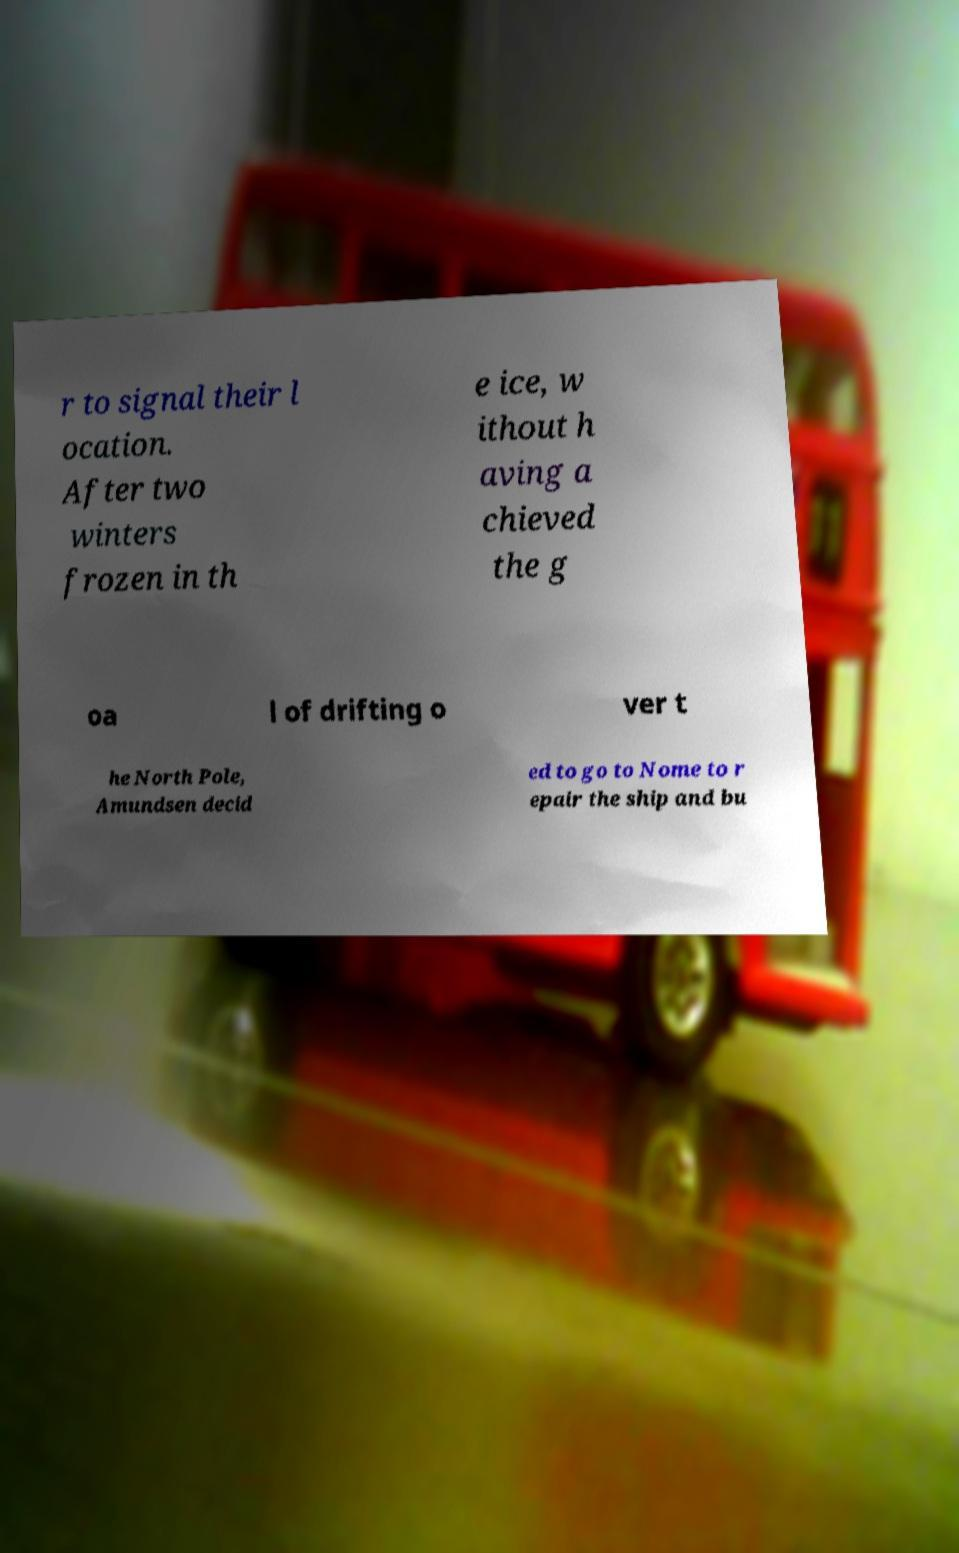Can you accurately transcribe the text from the provided image for me? r to signal their l ocation. After two winters frozen in th e ice, w ithout h aving a chieved the g oa l of drifting o ver t he North Pole, Amundsen decid ed to go to Nome to r epair the ship and bu 